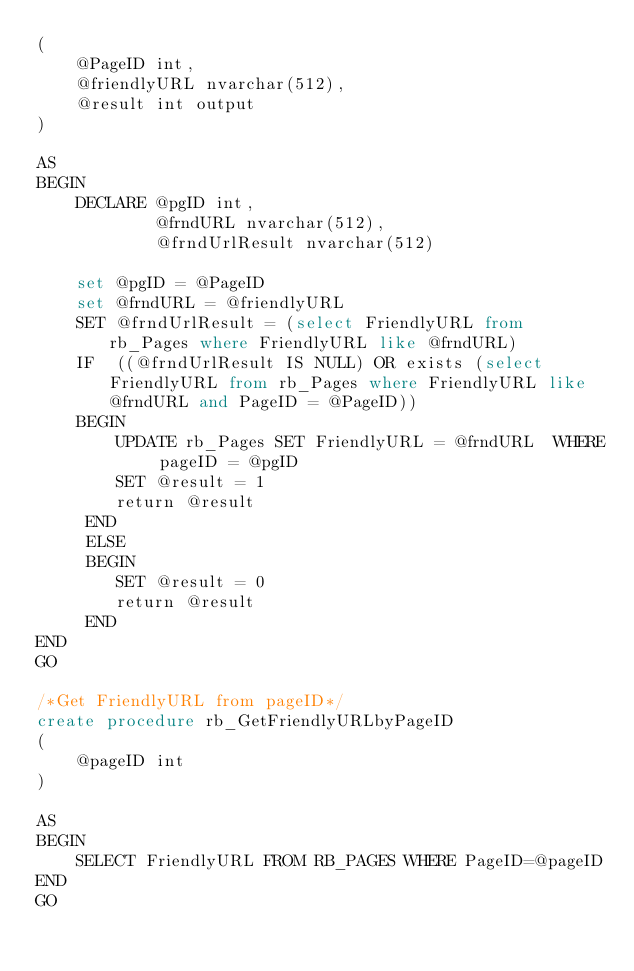<code> <loc_0><loc_0><loc_500><loc_500><_SQL_>(
	@PageID int,
	@friendlyURL nvarchar(512),
	@result int output
)

AS
BEGIN
	DECLARE @pgID int,
			@frndURL nvarchar(512),
			@frndUrlResult nvarchar(512)

	set @pgID = @PageID 
	set @frndURL = @friendlyURL 
	SET @frndUrlResult = (select FriendlyURL from rb_Pages where FriendlyURL like @frndURL)
	IF  ((@frndUrlResult IS NULL) OR exists (select FriendlyURL from rb_Pages where FriendlyURL like @frndURL and PageID = @PageID))
	BEGIN
		UPDATE rb_Pages SET FriendlyURL = @frndURL  WHERE pageID = @pgID
		SET @result = 1
		return @result
	 END
	 ELSE
	 BEGIN
		SET @result = 0
		return @result
	 END
END
GO

/*Get FriendlyURL from pageID*/
create procedure rb_GetFriendlyURLbyPageID
(
	@pageID int
)

AS
BEGIN
	SELECT FriendlyURL FROM RB_PAGES WHERE PageID=@pageID 
END
GO

</code> 